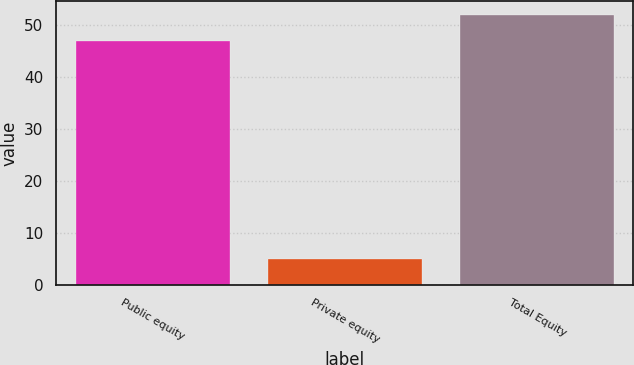Convert chart. <chart><loc_0><loc_0><loc_500><loc_500><bar_chart><fcel>Public equity<fcel>Private equity<fcel>Total Equity<nl><fcel>47<fcel>5<fcel>52<nl></chart> 